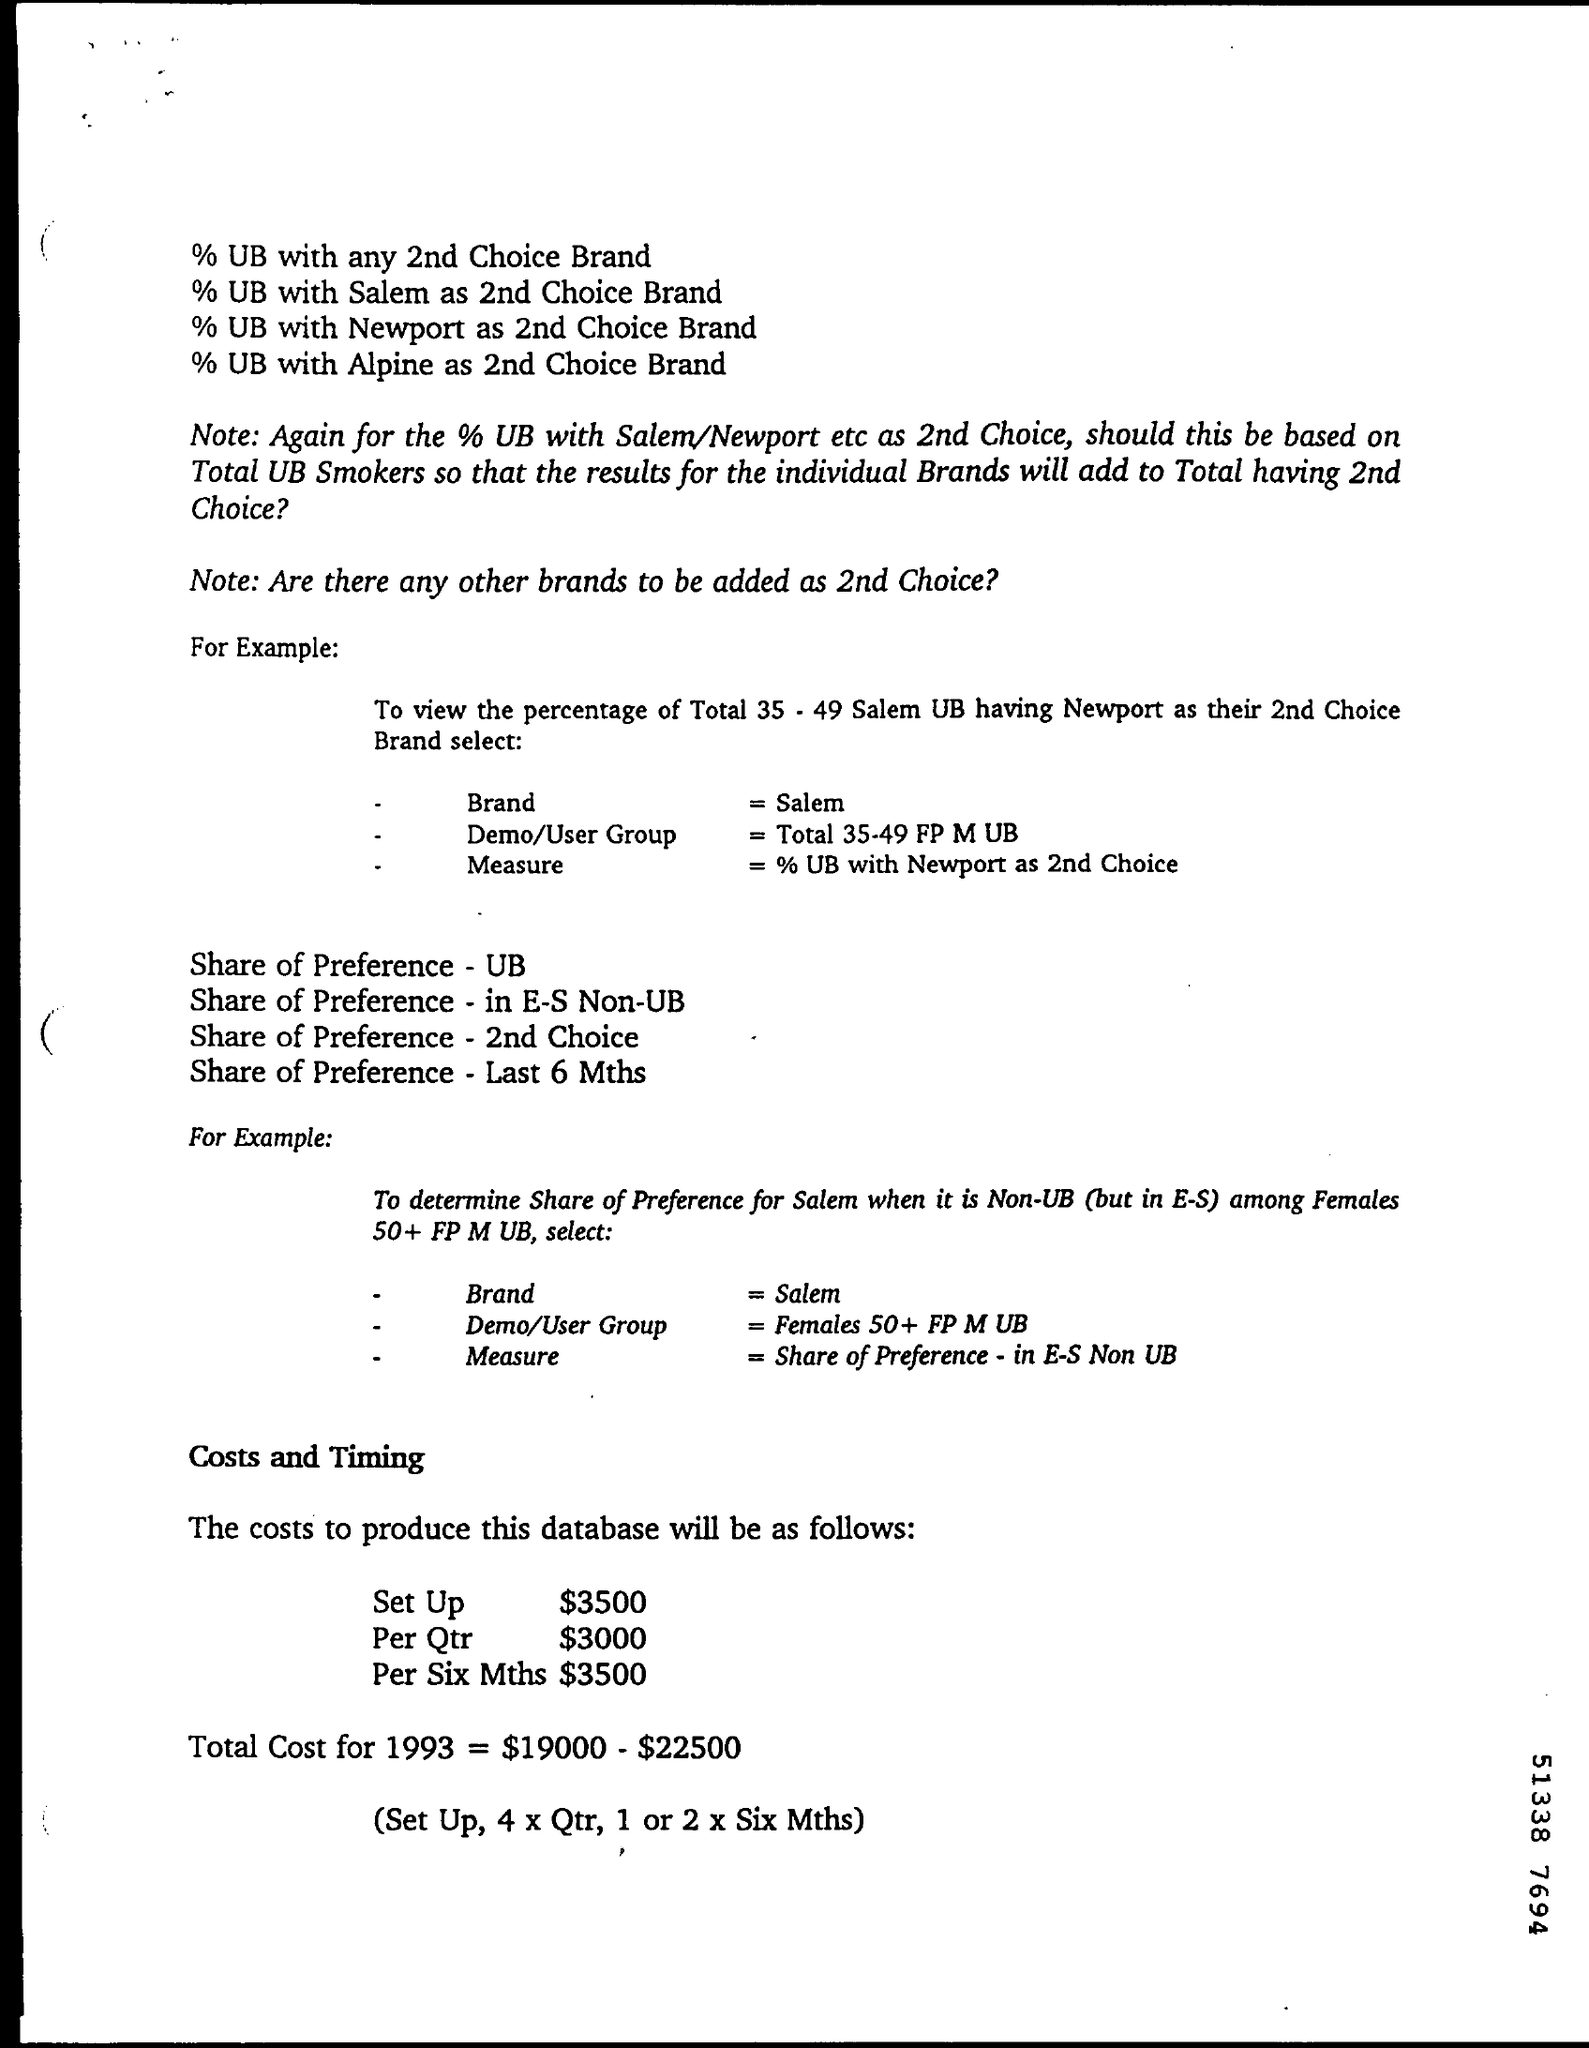What is Total Cost for 1993?
Give a very brief answer. $19000 - $22500. What is the Set Up cost?
Give a very brief answer. $3500. 